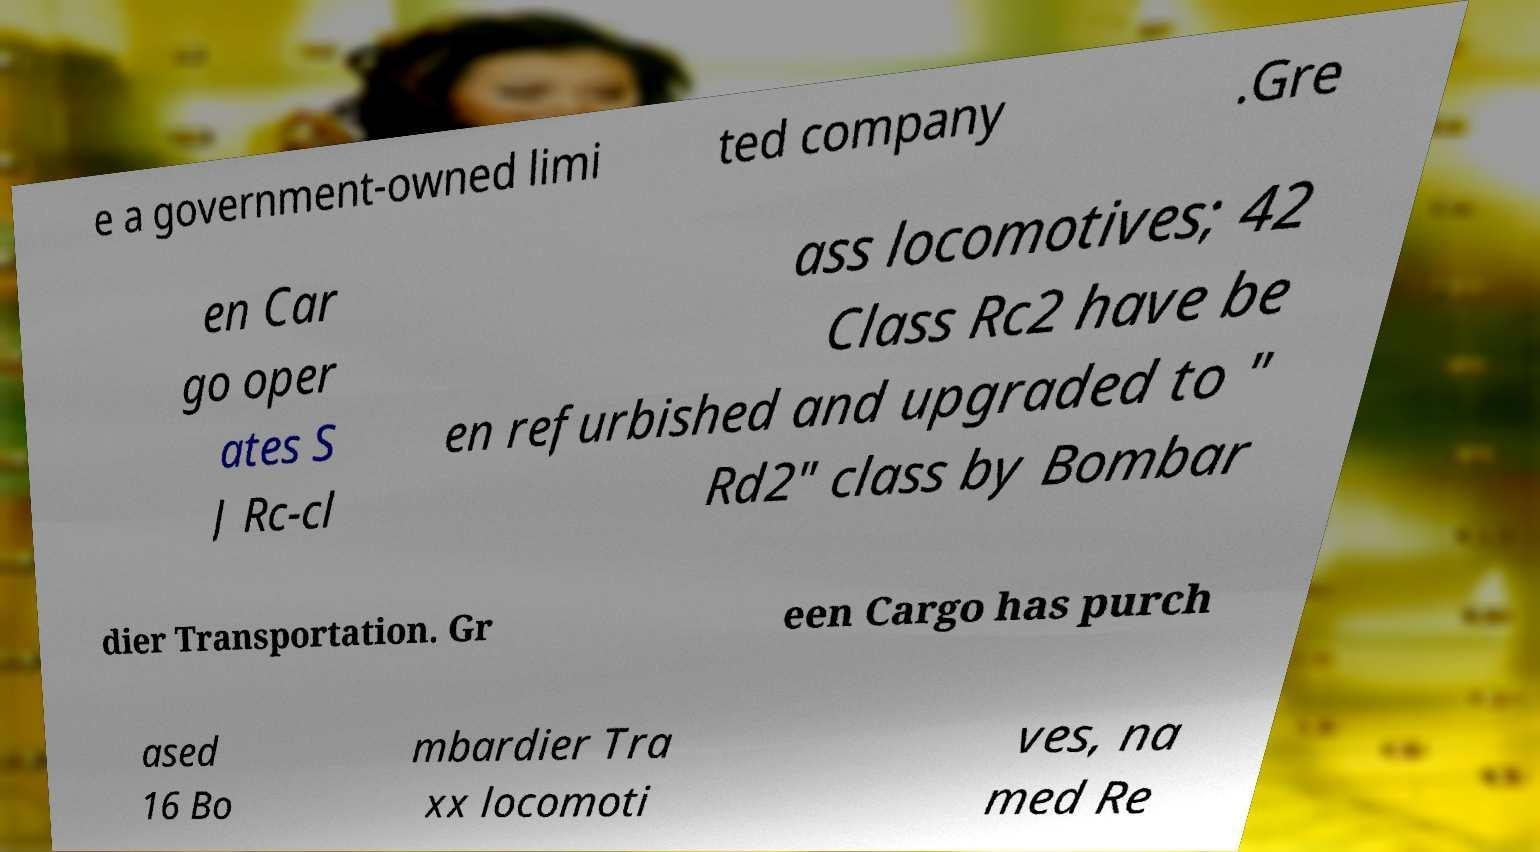Could you extract and type out the text from this image? e a government-owned limi ted company .Gre en Car go oper ates S J Rc-cl ass locomotives; 42 Class Rc2 have be en refurbished and upgraded to " Rd2" class by Bombar dier Transportation. Gr een Cargo has purch ased 16 Bo mbardier Tra xx locomoti ves, na med Re 